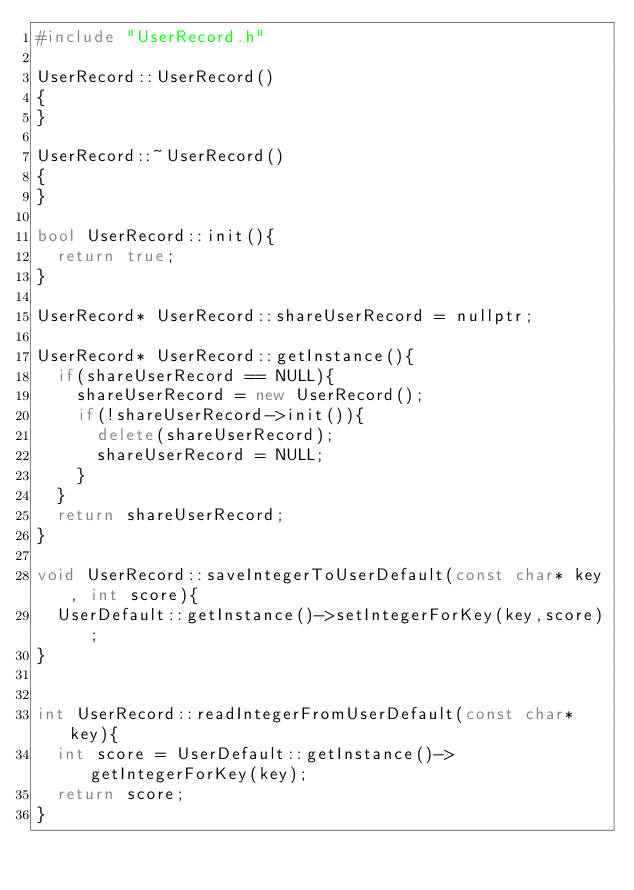<code> <loc_0><loc_0><loc_500><loc_500><_C++_>#include "UserRecord.h"

UserRecord::UserRecord()
{
}

UserRecord::~UserRecord()
{
}

bool UserRecord::init(){
	return true;
}

UserRecord* UserRecord::shareUserRecord = nullptr;

UserRecord* UserRecord::getInstance(){
	if(shareUserRecord == NULL){
		shareUserRecord = new UserRecord();
		if(!shareUserRecord->init()){
			delete(shareUserRecord);
			shareUserRecord = NULL;
		}
	}
	return shareUserRecord;
}

void UserRecord::saveIntegerToUserDefault(const char* key, int score){
	UserDefault::getInstance()->setIntegerForKey(key,score);	
}


int UserRecord::readIntegerFromUserDefault(const char* key){
	int score = UserDefault::getInstance()->getIntegerForKey(key);
	return score;
}</code> 